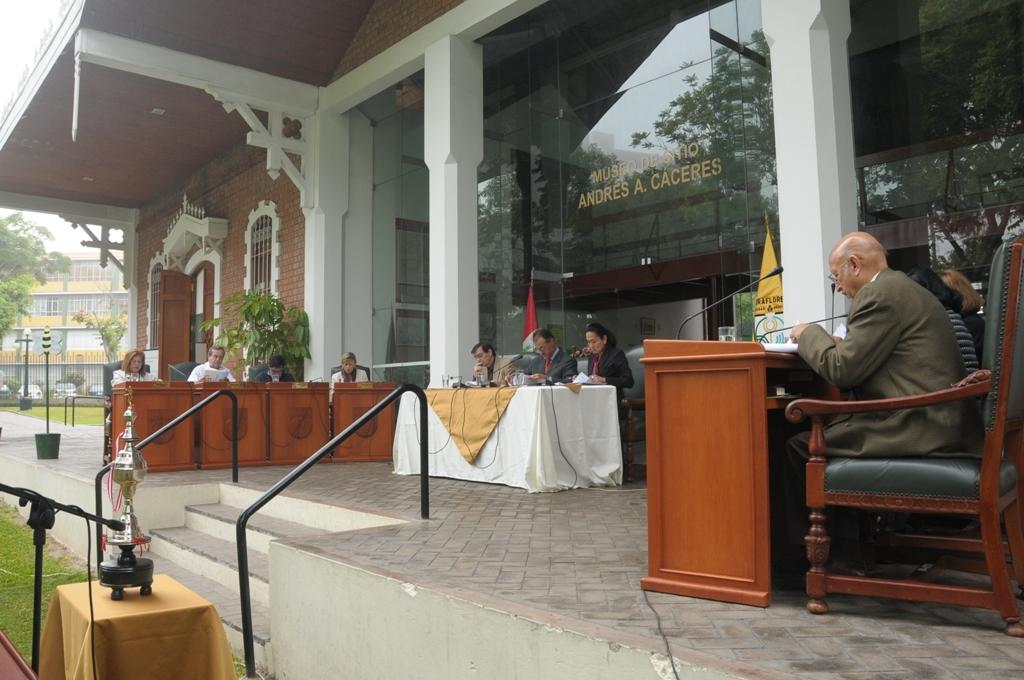How many people are in the image? There is a group of people in the image. What are the people doing in the image? The people are seated on chairs. What objects are on the table in the image? There are microphones on a table. What is happening in the image? There is a moment in the image. What architectural feature is present in the image? There are stairs in the image. What type of natural environment is visible in the image? There are trees in the image. What is the name of the lamp on the table in the image? There is no lamp present in the image; only microphones are on the table. What verse is being recited by the people in the image? There is no indication in the image that a verse is being recited; the people are simply seated with microphones on a table. 